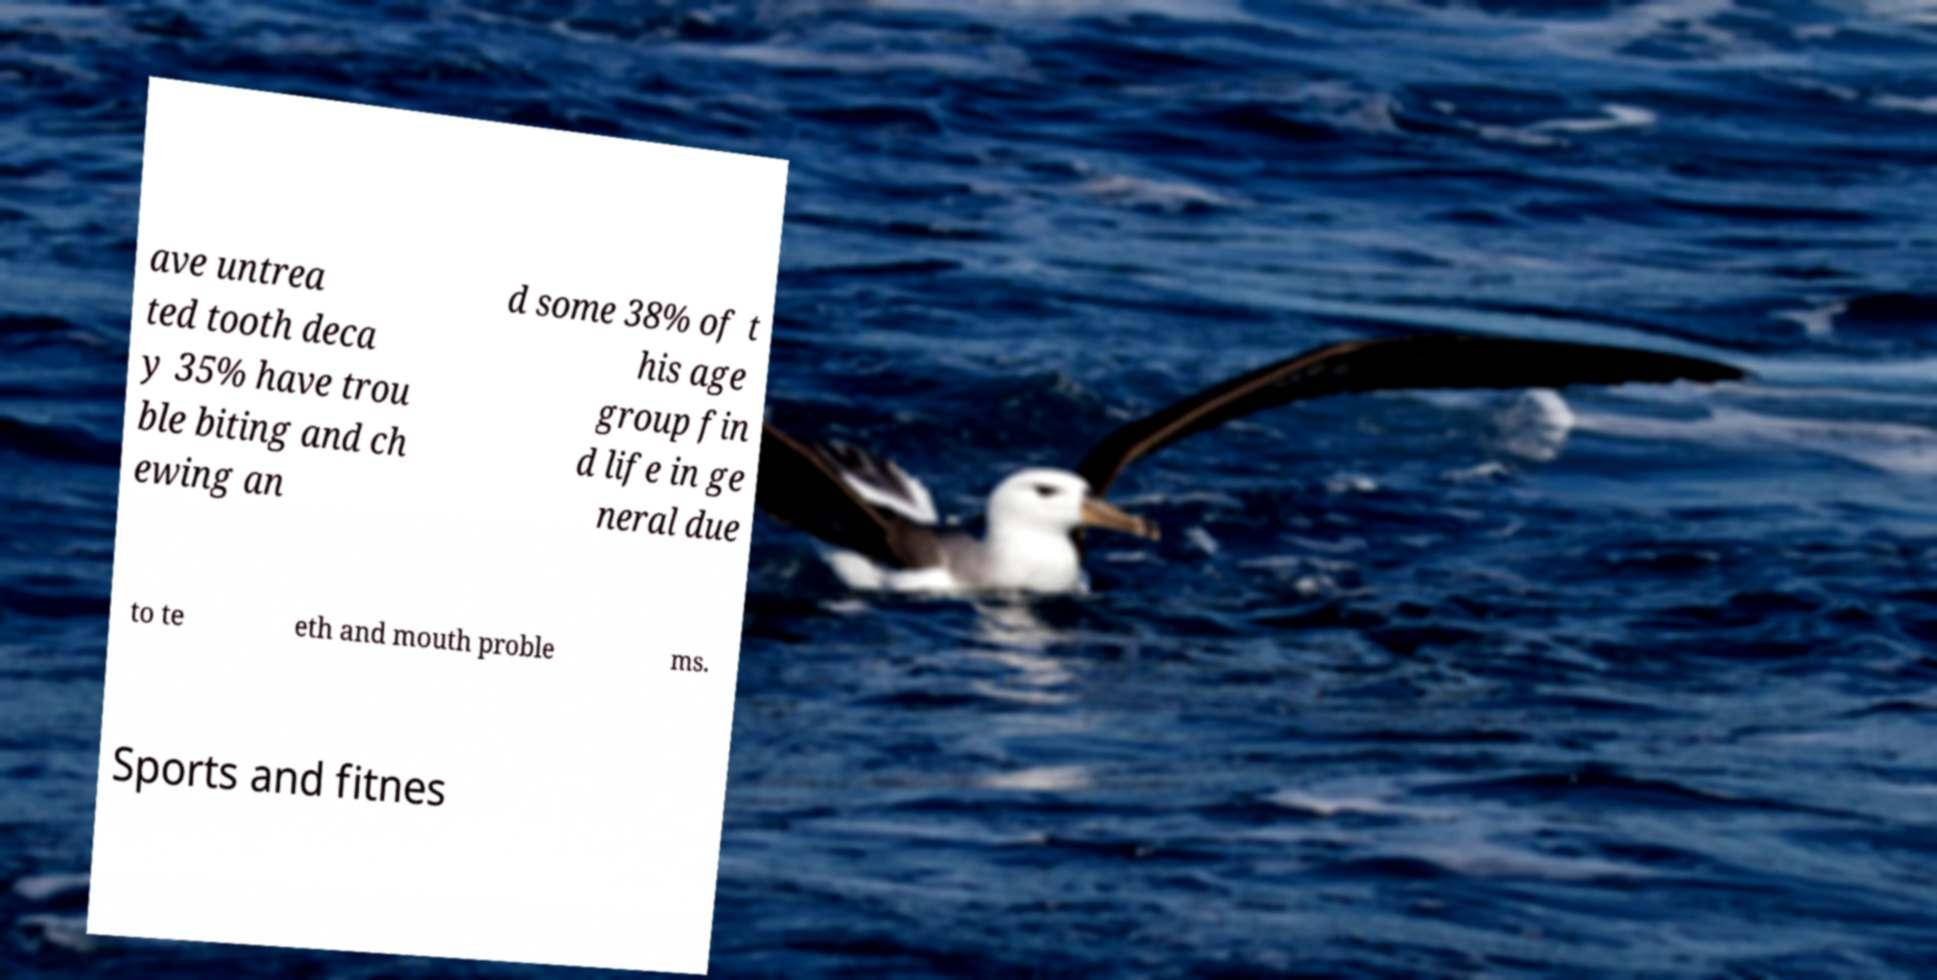Please read and relay the text visible in this image. What does it say? ave untrea ted tooth deca y 35% have trou ble biting and ch ewing an d some 38% of t his age group fin d life in ge neral due to te eth and mouth proble ms. Sports and fitnes 